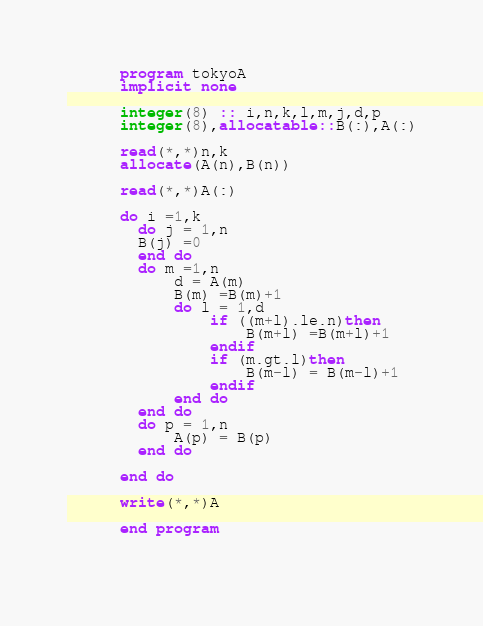<code> <loc_0><loc_0><loc_500><loc_500><_FORTRAN_>      program tokyoA
      implicit none

      integer(8) :: i,n,k,l,m,j,d,p
      integer(8),allocatable::B(:),A(:)

      read(*,*)n,k
      allocate(A(n),B(n))

      read(*,*)A(:)

      do i =1,k
        do j = 1,n
        B(j) =0
        end do
        do m =1,n
            d = A(m)
            B(m) =B(m)+1
            do l = 1,d
                if ((m+l).le.n)then
                    B(m+l) =B(m+l)+1
                endif
                if (m.gt.l)then
                    B(m-l) = B(m-l)+1
                endif
            end do
        end do
        do p = 1,n
            A(p) = B(p)
        end do

      end do

      write(*,*)A

      end program

      </code> 